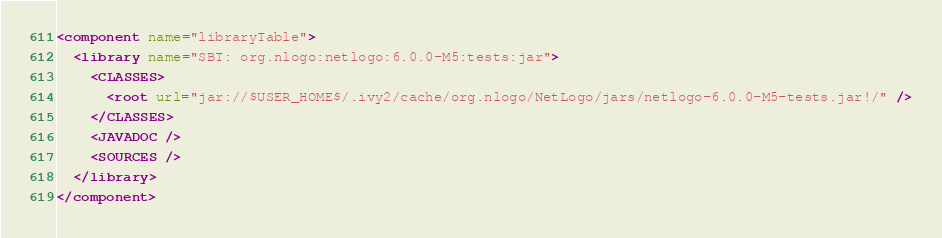Convert code to text. <code><loc_0><loc_0><loc_500><loc_500><_XML_><component name="libraryTable">
  <library name="SBT: org.nlogo:netlogo:6.0.0-M5:tests:jar">
    <CLASSES>
      <root url="jar://$USER_HOME$/.ivy2/cache/org.nlogo/NetLogo/jars/netlogo-6.0.0-M5-tests.jar!/" />
    </CLASSES>
    <JAVADOC />
    <SOURCES />
  </library>
</component></code> 